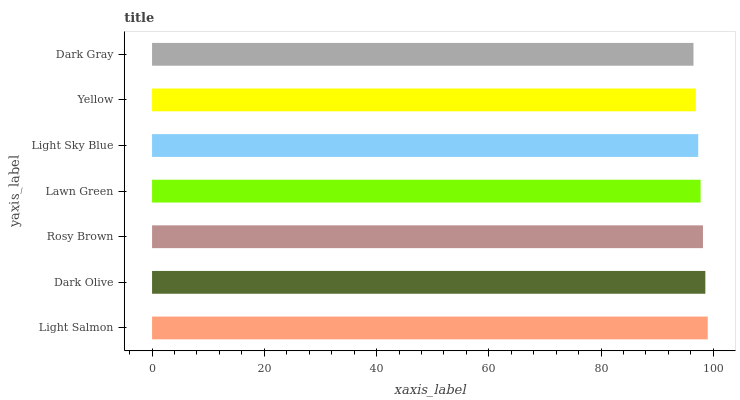Is Dark Gray the minimum?
Answer yes or no. Yes. Is Light Salmon the maximum?
Answer yes or no. Yes. Is Dark Olive the minimum?
Answer yes or no. No. Is Dark Olive the maximum?
Answer yes or no. No. Is Light Salmon greater than Dark Olive?
Answer yes or no. Yes. Is Dark Olive less than Light Salmon?
Answer yes or no. Yes. Is Dark Olive greater than Light Salmon?
Answer yes or no. No. Is Light Salmon less than Dark Olive?
Answer yes or no. No. Is Lawn Green the high median?
Answer yes or no. Yes. Is Lawn Green the low median?
Answer yes or no. Yes. Is Light Sky Blue the high median?
Answer yes or no. No. Is Dark Olive the low median?
Answer yes or no. No. 